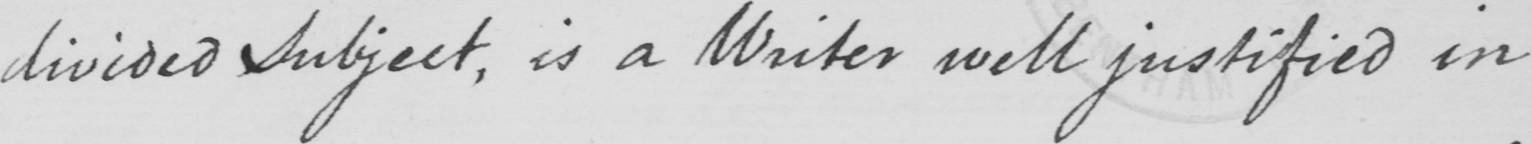What text is written in this handwritten line? divided subject , is a Writer well justified in 